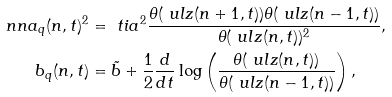Convert formula to latex. <formula><loc_0><loc_0><loc_500><loc_500>\ n n a _ { q } ( n , t ) ^ { 2 } & = \ t i { a } ^ { 2 } \frac { \theta ( \ u l z ( n + 1 , t ) ) \theta ( \ u l z ( n - 1 , t ) ) } { \theta ( \ u l z ( n , t ) ) ^ { 2 } } , \\ b _ { q } ( n , t ) & = \tilde { b } + \frac { 1 } { 2 } \frac { d } { d t } \log \left ( \frac { \theta ( \ u l z ( n , t ) ) } { \theta ( \ u l z ( n - 1 , t ) ) } \right ) ,</formula> 